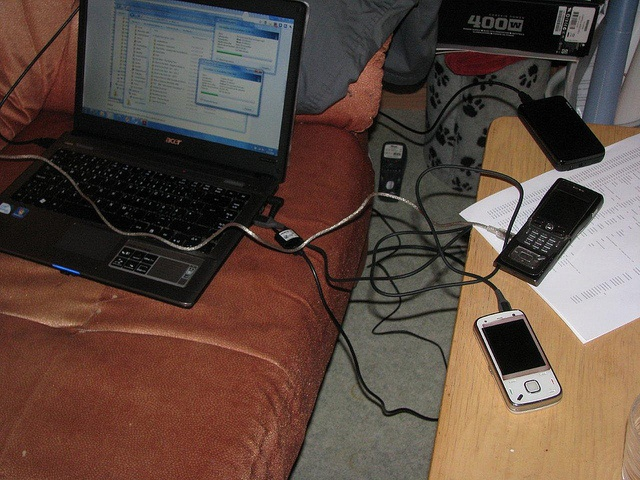Describe the objects in this image and their specific colors. I can see couch in brown, maroon, and black tones, laptop in brown, black, gray, and blue tones, dining table in brown, tan, black, and lightgray tones, people in brown, black, and purple tones, and cell phone in brown, black, gray, and darkgray tones in this image. 